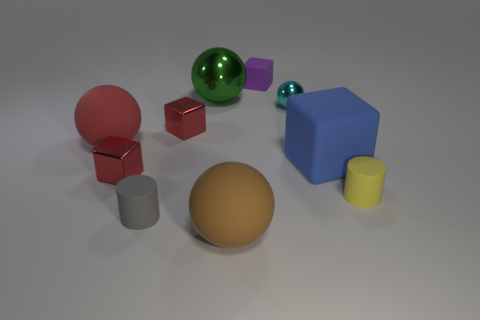Subtract all small blocks. How many blocks are left? 1 Subtract all gray balls. Subtract all yellow blocks. How many balls are left? 4 Subtract all cubes. How many objects are left? 6 Add 4 tiny shiny things. How many tiny shiny things are left? 7 Add 3 large red blocks. How many large red blocks exist? 3 Subtract 1 red spheres. How many objects are left? 9 Subtract all large purple metallic cylinders. Subtract all cyan metallic spheres. How many objects are left? 9 